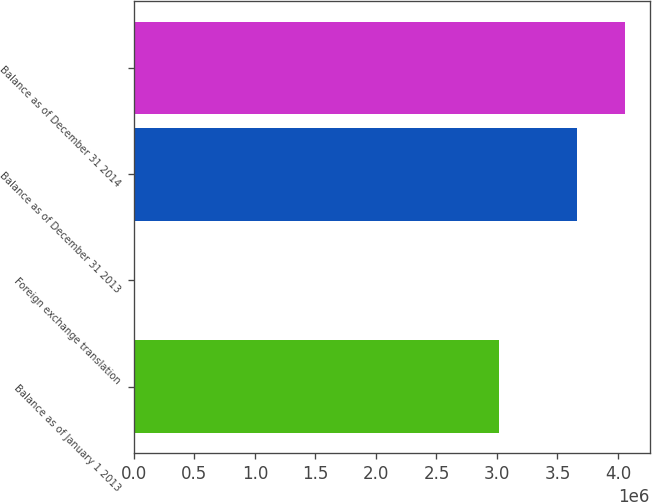Convert chart. <chart><loc_0><loc_0><loc_500><loc_500><bar_chart><fcel>Balance as of January 1 2013<fcel>Foreign exchange translation<fcel>Balance as of December 31 2013<fcel>Balance as of December 31 2014<nl><fcel>3.01567e+06<fcel>11559<fcel>3.66367e+06<fcel>4.05811e+06<nl></chart> 